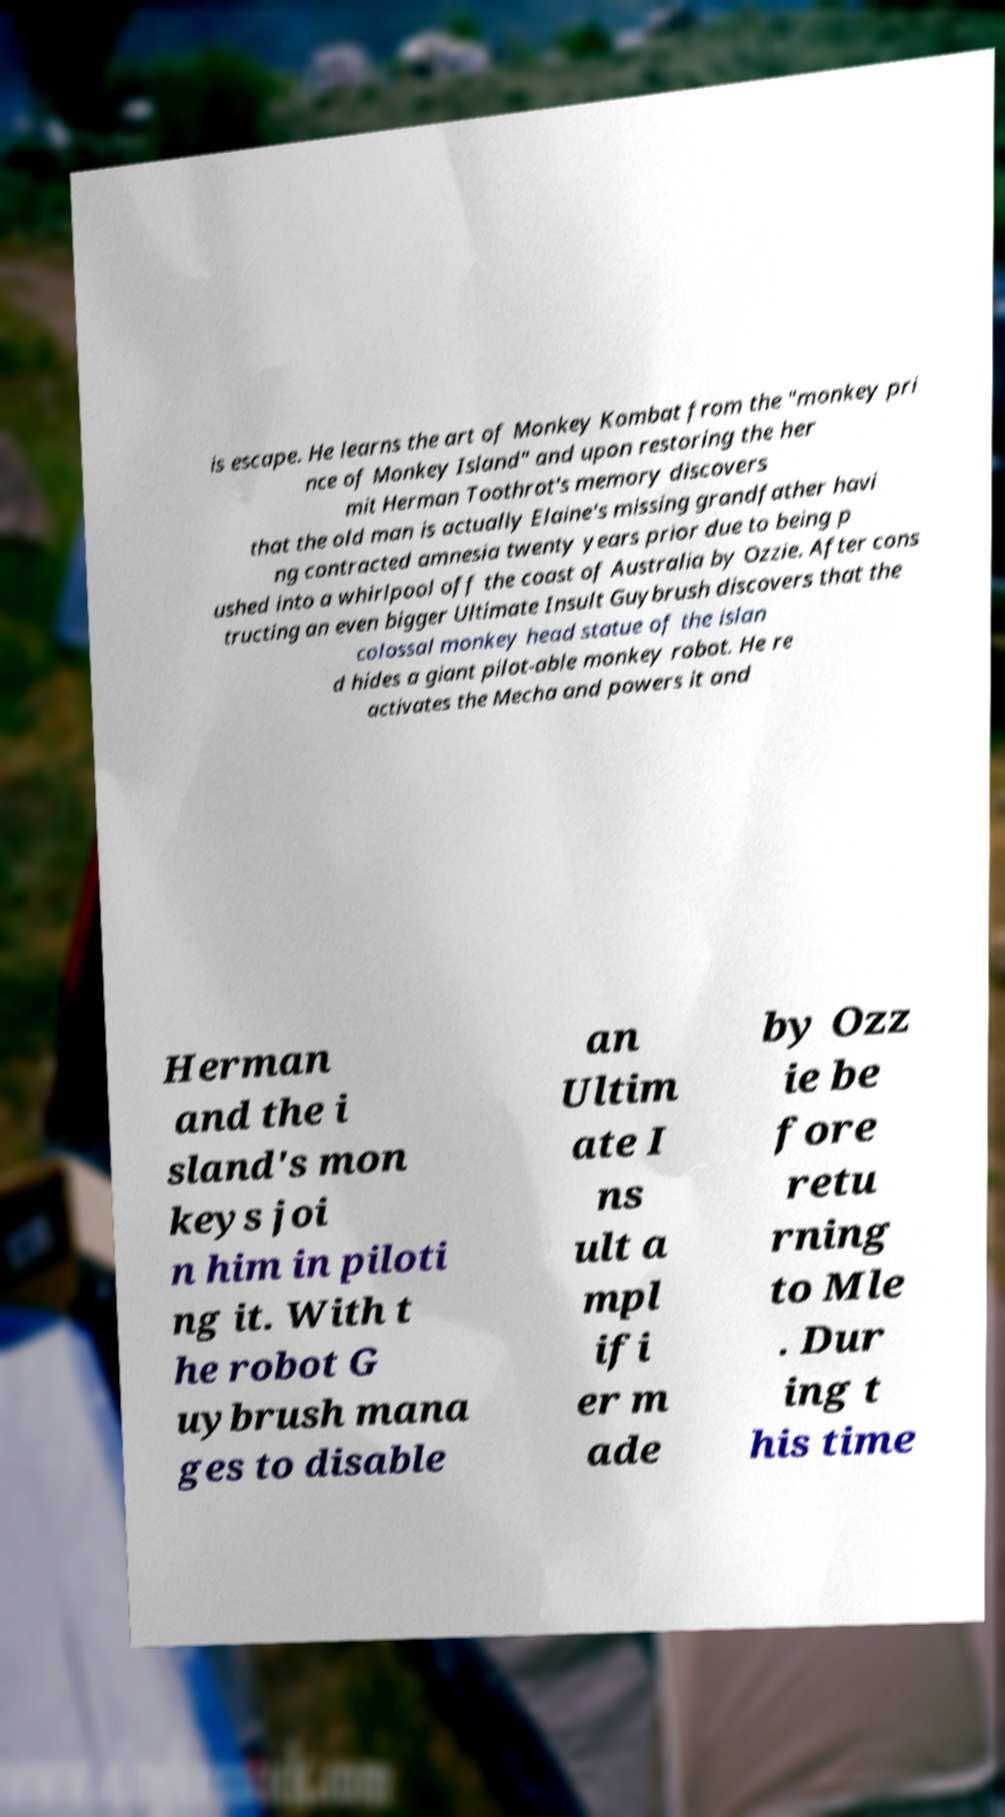For documentation purposes, I need the text within this image transcribed. Could you provide that? is escape. He learns the art of Monkey Kombat from the "monkey pri nce of Monkey Island" and upon restoring the her mit Herman Toothrot's memory discovers that the old man is actually Elaine's missing grandfather havi ng contracted amnesia twenty years prior due to being p ushed into a whirlpool off the coast of Australia by Ozzie. After cons tructing an even bigger Ultimate Insult Guybrush discovers that the colossal monkey head statue of the islan d hides a giant pilot-able monkey robot. He re activates the Mecha and powers it and Herman and the i sland's mon keys joi n him in piloti ng it. With t he robot G uybrush mana ges to disable an Ultim ate I ns ult a mpl ifi er m ade by Ozz ie be fore retu rning to Mle . Dur ing t his time 